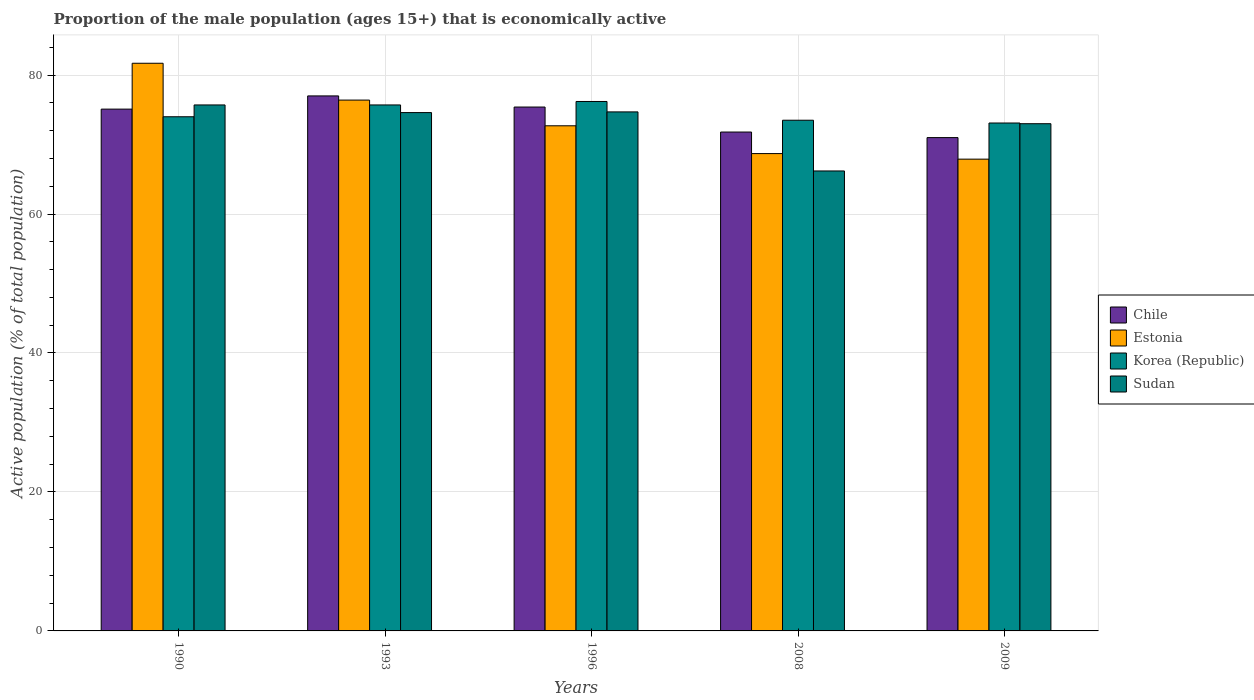Are the number of bars per tick equal to the number of legend labels?
Your answer should be compact. Yes. Are the number of bars on each tick of the X-axis equal?
Make the answer very short. Yes. How many bars are there on the 1st tick from the left?
Give a very brief answer. 4. How many bars are there on the 1st tick from the right?
Your answer should be very brief. 4. In how many cases, is the number of bars for a given year not equal to the number of legend labels?
Make the answer very short. 0. Across all years, what is the maximum proportion of the male population that is economically active in Korea (Republic)?
Provide a succinct answer. 76.2. Across all years, what is the minimum proportion of the male population that is economically active in Estonia?
Offer a terse response. 67.9. In which year was the proportion of the male population that is economically active in Korea (Republic) maximum?
Give a very brief answer. 1996. What is the total proportion of the male population that is economically active in Korea (Republic) in the graph?
Provide a short and direct response. 372.5. What is the difference between the proportion of the male population that is economically active in Estonia in 1993 and that in 1996?
Your answer should be very brief. 3.7. What is the difference between the proportion of the male population that is economically active in Chile in 1993 and the proportion of the male population that is economically active in Korea (Republic) in 1996?
Make the answer very short. 0.8. What is the average proportion of the male population that is economically active in Korea (Republic) per year?
Give a very brief answer. 74.5. In the year 2009, what is the difference between the proportion of the male population that is economically active in Sudan and proportion of the male population that is economically active in Korea (Republic)?
Keep it short and to the point. -0.1. What is the ratio of the proportion of the male population that is economically active in Chile in 1996 to that in 2008?
Offer a terse response. 1.05. Is it the case that in every year, the sum of the proportion of the male population that is economically active in Korea (Republic) and proportion of the male population that is economically active in Estonia is greater than the sum of proportion of the male population that is economically active in Chile and proportion of the male population that is economically active in Sudan?
Make the answer very short. No. What does the 2nd bar from the left in 1993 represents?
Keep it short and to the point. Estonia. What does the 2nd bar from the right in 1996 represents?
Ensure brevity in your answer.  Korea (Republic). Is it the case that in every year, the sum of the proportion of the male population that is economically active in Estonia and proportion of the male population that is economically active in Sudan is greater than the proportion of the male population that is economically active in Chile?
Your response must be concise. Yes. Are the values on the major ticks of Y-axis written in scientific E-notation?
Your response must be concise. No. Does the graph contain grids?
Give a very brief answer. Yes. Where does the legend appear in the graph?
Ensure brevity in your answer.  Center right. How are the legend labels stacked?
Give a very brief answer. Vertical. What is the title of the graph?
Your answer should be compact. Proportion of the male population (ages 15+) that is economically active. What is the label or title of the Y-axis?
Ensure brevity in your answer.  Active population (% of total population). What is the Active population (% of total population) of Chile in 1990?
Provide a succinct answer. 75.1. What is the Active population (% of total population) in Estonia in 1990?
Ensure brevity in your answer.  81.7. What is the Active population (% of total population) of Korea (Republic) in 1990?
Make the answer very short. 74. What is the Active population (% of total population) in Sudan in 1990?
Keep it short and to the point. 75.7. What is the Active population (% of total population) in Estonia in 1993?
Make the answer very short. 76.4. What is the Active population (% of total population) in Korea (Republic) in 1993?
Ensure brevity in your answer.  75.7. What is the Active population (% of total population) in Sudan in 1993?
Offer a terse response. 74.6. What is the Active population (% of total population) of Chile in 1996?
Give a very brief answer. 75.4. What is the Active population (% of total population) of Estonia in 1996?
Give a very brief answer. 72.7. What is the Active population (% of total population) in Korea (Republic) in 1996?
Ensure brevity in your answer.  76.2. What is the Active population (% of total population) in Sudan in 1996?
Your answer should be very brief. 74.7. What is the Active population (% of total population) in Chile in 2008?
Provide a succinct answer. 71.8. What is the Active population (% of total population) of Estonia in 2008?
Offer a terse response. 68.7. What is the Active population (% of total population) of Korea (Republic) in 2008?
Provide a short and direct response. 73.5. What is the Active population (% of total population) of Sudan in 2008?
Provide a succinct answer. 66.2. What is the Active population (% of total population) in Chile in 2009?
Your answer should be very brief. 71. What is the Active population (% of total population) of Estonia in 2009?
Offer a very short reply. 67.9. What is the Active population (% of total population) of Korea (Republic) in 2009?
Make the answer very short. 73.1. What is the Active population (% of total population) in Sudan in 2009?
Your answer should be very brief. 73. Across all years, what is the maximum Active population (% of total population) of Chile?
Ensure brevity in your answer.  77. Across all years, what is the maximum Active population (% of total population) in Estonia?
Offer a terse response. 81.7. Across all years, what is the maximum Active population (% of total population) in Korea (Republic)?
Keep it short and to the point. 76.2. Across all years, what is the maximum Active population (% of total population) of Sudan?
Offer a very short reply. 75.7. Across all years, what is the minimum Active population (% of total population) in Chile?
Provide a succinct answer. 71. Across all years, what is the minimum Active population (% of total population) in Estonia?
Your response must be concise. 67.9. Across all years, what is the minimum Active population (% of total population) in Korea (Republic)?
Offer a terse response. 73.1. Across all years, what is the minimum Active population (% of total population) of Sudan?
Provide a short and direct response. 66.2. What is the total Active population (% of total population) in Chile in the graph?
Offer a very short reply. 370.3. What is the total Active population (% of total population) of Estonia in the graph?
Ensure brevity in your answer.  367.4. What is the total Active population (% of total population) in Korea (Republic) in the graph?
Make the answer very short. 372.5. What is the total Active population (% of total population) in Sudan in the graph?
Your answer should be compact. 364.2. What is the difference between the Active population (% of total population) in Chile in 1990 and that in 1993?
Ensure brevity in your answer.  -1.9. What is the difference between the Active population (% of total population) in Korea (Republic) in 1990 and that in 1993?
Your response must be concise. -1.7. What is the difference between the Active population (% of total population) of Sudan in 1990 and that in 1993?
Provide a short and direct response. 1.1. What is the difference between the Active population (% of total population) in Estonia in 1990 and that in 1996?
Offer a very short reply. 9. What is the difference between the Active population (% of total population) in Korea (Republic) in 1990 and that in 1996?
Provide a succinct answer. -2.2. What is the difference between the Active population (% of total population) of Estonia in 1990 and that in 2008?
Keep it short and to the point. 13. What is the difference between the Active population (% of total population) in Sudan in 1990 and that in 2008?
Give a very brief answer. 9.5. What is the difference between the Active population (% of total population) of Chile in 1990 and that in 2009?
Make the answer very short. 4.1. What is the difference between the Active population (% of total population) in Estonia in 1990 and that in 2009?
Your answer should be compact. 13.8. What is the difference between the Active population (% of total population) in Korea (Republic) in 1990 and that in 2009?
Your response must be concise. 0.9. What is the difference between the Active population (% of total population) in Sudan in 1990 and that in 2009?
Ensure brevity in your answer.  2.7. What is the difference between the Active population (% of total population) of Chile in 1993 and that in 1996?
Your response must be concise. 1.6. What is the difference between the Active population (% of total population) of Sudan in 1993 and that in 1996?
Ensure brevity in your answer.  -0.1. What is the difference between the Active population (% of total population) in Estonia in 1993 and that in 2008?
Your answer should be very brief. 7.7. What is the difference between the Active population (% of total population) in Korea (Republic) in 1993 and that in 2008?
Provide a short and direct response. 2.2. What is the difference between the Active population (% of total population) of Chile in 1993 and that in 2009?
Your answer should be very brief. 6. What is the difference between the Active population (% of total population) in Korea (Republic) in 1993 and that in 2009?
Your response must be concise. 2.6. What is the difference between the Active population (% of total population) in Sudan in 1993 and that in 2009?
Your answer should be very brief. 1.6. What is the difference between the Active population (% of total population) of Estonia in 1996 and that in 2008?
Your answer should be very brief. 4. What is the difference between the Active population (% of total population) in Sudan in 1996 and that in 2008?
Your answer should be compact. 8.5. What is the difference between the Active population (% of total population) in Estonia in 1996 and that in 2009?
Your answer should be very brief. 4.8. What is the difference between the Active population (% of total population) in Korea (Republic) in 1996 and that in 2009?
Your response must be concise. 3.1. What is the difference between the Active population (% of total population) of Chile in 1990 and the Active population (% of total population) of Estonia in 1993?
Offer a very short reply. -1.3. What is the difference between the Active population (% of total population) of Chile in 1990 and the Active population (% of total population) of Korea (Republic) in 1993?
Ensure brevity in your answer.  -0.6. What is the difference between the Active population (% of total population) in Chile in 1990 and the Active population (% of total population) in Sudan in 1993?
Offer a very short reply. 0.5. What is the difference between the Active population (% of total population) of Estonia in 1990 and the Active population (% of total population) of Korea (Republic) in 1993?
Offer a terse response. 6. What is the difference between the Active population (% of total population) of Korea (Republic) in 1990 and the Active population (% of total population) of Sudan in 1993?
Ensure brevity in your answer.  -0.6. What is the difference between the Active population (% of total population) in Chile in 1990 and the Active population (% of total population) in Estonia in 2008?
Your answer should be compact. 6.4. What is the difference between the Active population (% of total population) in Estonia in 1990 and the Active population (% of total population) in Korea (Republic) in 2008?
Offer a terse response. 8.2. What is the difference between the Active population (% of total population) of Korea (Republic) in 1990 and the Active population (% of total population) of Sudan in 2008?
Keep it short and to the point. 7.8. What is the difference between the Active population (% of total population) of Chile in 1990 and the Active population (% of total population) of Estonia in 2009?
Keep it short and to the point. 7.2. What is the difference between the Active population (% of total population) in Chile in 1990 and the Active population (% of total population) in Korea (Republic) in 2009?
Your answer should be very brief. 2. What is the difference between the Active population (% of total population) of Chile in 1990 and the Active population (% of total population) of Sudan in 2009?
Provide a short and direct response. 2.1. What is the difference between the Active population (% of total population) in Estonia in 1990 and the Active population (% of total population) in Sudan in 2009?
Keep it short and to the point. 8.7. What is the difference between the Active population (% of total population) of Chile in 1993 and the Active population (% of total population) of Estonia in 1996?
Keep it short and to the point. 4.3. What is the difference between the Active population (% of total population) of Chile in 1993 and the Active population (% of total population) of Korea (Republic) in 1996?
Keep it short and to the point. 0.8. What is the difference between the Active population (% of total population) in Chile in 1993 and the Active population (% of total population) in Sudan in 1996?
Keep it short and to the point. 2.3. What is the difference between the Active population (% of total population) of Korea (Republic) in 1993 and the Active population (% of total population) of Sudan in 1996?
Ensure brevity in your answer.  1. What is the difference between the Active population (% of total population) of Chile in 1993 and the Active population (% of total population) of Korea (Republic) in 2008?
Provide a short and direct response. 3.5. What is the difference between the Active population (% of total population) of Chile in 1993 and the Active population (% of total population) of Sudan in 2008?
Ensure brevity in your answer.  10.8. What is the difference between the Active population (% of total population) in Chile in 1993 and the Active population (% of total population) in Sudan in 2009?
Your answer should be compact. 4. What is the difference between the Active population (% of total population) of Estonia in 1993 and the Active population (% of total population) of Sudan in 2009?
Provide a short and direct response. 3.4. What is the difference between the Active population (% of total population) in Chile in 1996 and the Active population (% of total population) in Korea (Republic) in 2008?
Your answer should be compact. 1.9. What is the difference between the Active population (% of total population) in Chile in 1996 and the Active population (% of total population) in Sudan in 2008?
Ensure brevity in your answer.  9.2. What is the difference between the Active population (% of total population) in Korea (Republic) in 1996 and the Active population (% of total population) in Sudan in 2008?
Provide a succinct answer. 10. What is the difference between the Active population (% of total population) in Chile in 1996 and the Active population (% of total population) in Korea (Republic) in 2009?
Make the answer very short. 2.3. What is the difference between the Active population (% of total population) in Chile in 1996 and the Active population (% of total population) in Sudan in 2009?
Ensure brevity in your answer.  2.4. What is the difference between the Active population (% of total population) of Estonia in 1996 and the Active population (% of total population) of Korea (Republic) in 2009?
Ensure brevity in your answer.  -0.4. What is the difference between the Active population (% of total population) in Korea (Republic) in 1996 and the Active population (% of total population) in Sudan in 2009?
Your answer should be very brief. 3.2. What is the difference between the Active population (% of total population) in Chile in 2008 and the Active population (% of total population) in Korea (Republic) in 2009?
Keep it short and to the point. -1.3. What is the difference between the Active population (% of total population) in Estonia in 2008 and the Active population (% of total population) in Sudan in 2009?
Your answer should be compact. -4.3. What is the average Active population (% of total population) of Chile per year?
Your response must be concise. 74.06. What is the average Active population (% of total population) of Estonia per year?
Offer a very short reply. 73.48. What is the average Active population (% of total population) in Korea (Republic) per year?
Your response must be concise. 74.5. What is the average Active population (% of total population) in Sudan per year?
Make the answer very short. 72.84. In the year 1990, what is the difference between the Active population (% of total population) in Chile and Active population (% of total population) in Estonia?
Provide a short and direct response. -6.6. In the year 1990, what is the difference between the Active population (% of total population) of Chile and Active population (% of total population) of Korea (Republic)?
Your answer should be very brief. 1.1. In the year 1990, what is the difference between the Active population (% of total population) in Chile and Active population (% of total population) in Sudan?
Provide a short and direct response. -0.6. In the year 1993, what is the difference between the Active population (% of total population) in Korea (Republic) and Active population (% of total population) in Sudan?
Offer a very short reply. 1.1. In the year 1996, what is the difference between the Active population (% of total population) of Chile and Active population (% of total population) of Sudan?
Offer a very short reply. 0.7. In the year 1996, what is the difference between the Active population (% of total population) of Estonia and Active population (% of total population) of Korea (Republic)?
Offer a very short reply. -3.5. In the year 1996, what is the difference between the Active population (% of total population) of Estonia and Active population (% of total population) of Sudan?
Provide a short and direct response. -2. In the year 2008, what is the difference between the Active population (% of total population) in Chile and Active population (% of total population) in Korea (Republic)?
Offer a very short reply. -1.7. In the year 2008, what is the difference between the Active population (% of total population) in Chile and Active population (% of total population) in Sudan?
Keep it short and to the point. 5.6. In the year 2008, what is the difference between the Active population (% of total population) of Estonia and Active population (% of total population) of Sudan?
Your answer should be very brief. 2.5. In the year 2008, what is the difference between the Active population (% of total population) in Korea (Republic) and Active population (% of total population) in Sudan?
Give a very brief answer. 7.3. In the year 2009, what is the difference between the Active population (% of total population) of Estonia and Active population (% of total population) of Korea (Republic)?
Your response must be concise. -5.2. In the year 2009, what is the difference between the Active population (% of total population) in Estonia and Active population (% of total population) in Sudan?
Provide a succinct answer. -5.1. What is the ratio of the Active population (% of total population) of Chile in 1990 to that in 1993?
Provide a short and direct response. 0.98. What is the ratio of the Active population (% of total population) of Estonia in 1990 to that in 1993?
Ensure brevity in your answer.  1.07. What is the ratio of the Active population (% of total population) in Korea (Republic) in 1990 to that in 1993?
Ensure brevity in your answer.  0.98. What is the ratio of the Active population (% of total population) of Sudan in 1990 to that in 1993?
Give a very brief answer. 1.01. What is the ratio of the Active population (% of total population) in Estonia in 1990 to that in 1996?
Make the answer very short. 1.12. What is the ratio of the Active population (% of total population) of Korea (Republic) in 1990 to that in 1996?
Your response must be concise. 0.97. What is the ratio of the Active population (% of total population) of Sudan in 1990 to that in 1996?
Give a very brief answer. 1.01. What is the ratio of the Active population (% of total population) of Chile in 1990 to that in 2008?
Ensure brevity in your answer.  1.05. What is the ratio of the Active population (% of total population) in Estonia in 1990 to that in 2008?
Your answer should be compact. 1.19. What is the ratio of the Active population (% of total population) of Korea (Republic) in 1990 to that in 2008?
Keep it short and to the point. 1.01. What is the ratio of the Active population (% of total population) of Sudan in 1990 to that in 2008?
Offer a terse response. 1.14. What is the ratio of the Active population (% of total population) in Chile in 1990 to that in 2009?
Your answer should be very brief. 1.06. What is the ratio of the Active population (% of total population) in Estonia in 1990 to that in 2009?
Give a very brief answer. 1.2. What is the ratio of the Active population (% of total population) of Korea (Republic) in 1990 to that in 2009?
Keep it short and to the point. 1.01. What is the ratio of the Active population (% of total population) in Sudan in 1990 to that in 2009?
Your response must be concise. 1.04. What is the ratio of the Active population (% of total population) in Chile in 1993 to that in 1996?
Your response must be concise. 1.02. What is the ratio of the Active population (% of total population) in Estonia in 1993 to that in 1996?
Keep it short and to the point. 1.05. What is the ratio of the Active population (% of total population) of Sudan in 1993 to that in 1996?
Offer a very short reply. 1. What is the ratio of the Active population (% of total population) in Chile in 1993 to that in 2008?
Your answer should be very brief. 1.07. What is the ratio of the Active population (% of total population) of Estonia in 1993 to that in 2008?
Ensure brevity in your answer.  1.11. What is the ratio of the Active population (% of total population) in Korea (Republic) in 1993 to that in 2008?
Provide a succinct answer. 1.03. What is the ratio of the Active population (% of total population) in Sudan in 1993 to that in 2008?
Give a very brief answer. 1.13. What is the ratio of the Active population (% of total population) of Chile in 1993 to that in 2009?
Ensure brevity in your answer.  1.08. What is the ratio of the Active population (% of total population) of Estonia in 1993 to that in 2009?
Ensure brevity in your answer.  1.13. What is the ratio of the Active population (% of total population) in Korea (Republic) in 1993 to that in 2009?
Provide a short and direct response. 1.04. What is the ratio of the Active population (% of total population) of Sudan in 1993 to that in 2009?
Provide a succinct answer. 1.02. What is the ratio of the Active population (% of total population) of Chile in 1996 to that in 2008?
Offer a very short reply. 1.05. What is the ratio of the Active population (% of total population) in Estonia in 1996 to that in 2008?
Make the answer very short. 1.06. What is the ratio of the Active population (% of total population) of Korea (Republic) in 1996 to that in 2008?
Keep it short and to the point. 1.04. What is the ratio of the Active population (% of total population) of Sudan in 1996 to that in 2008?
Give a very brief answer. 1.13. What is the ratio of the Active population (% of total population) in Chile in 1996 to that in 2009?
Keep it short and to the point. 1.06. What is the ratio of the Active population (% of total population) in Estonia in 1996 to that in 2009?
Make the answer very short. 1.07. What is the ratio of the Active population (% of total population) in Korea (Republic) in 1996 to that in 2009?
Ensure brevity in your answer.  1.04. What is the ratio of the Active population (% of total population) in Sudan in 1996 to that in 2009?
Your answer should be compact. 1.02. What is the ratio of the Active population (% of total population) in Chile in 2008 to that in 2009?
Keep it short and to the point. 1.01. What is the ratio of the Active population (% of total population) in Estonia in 2008 to that in 2009?
Give a very brief answer. 1.01. What is the ratio of the Active population (% of total population) in Korea (Republic) in 2008 to that in 2009?
Keep it short and to the point. 1.01. What is the ratio of the Active population (% of total population) of Sudan in 2008 to that in 2009?
Your response must be concise. 0.91. What is the difference between the highest and the lowest Active population (% of total population) in Chile?
Make the answer very short. 6. What is the difference between the highest and the lowest Active population (% of total population) in Sudan?
Offer a very short reply. 9.5. 